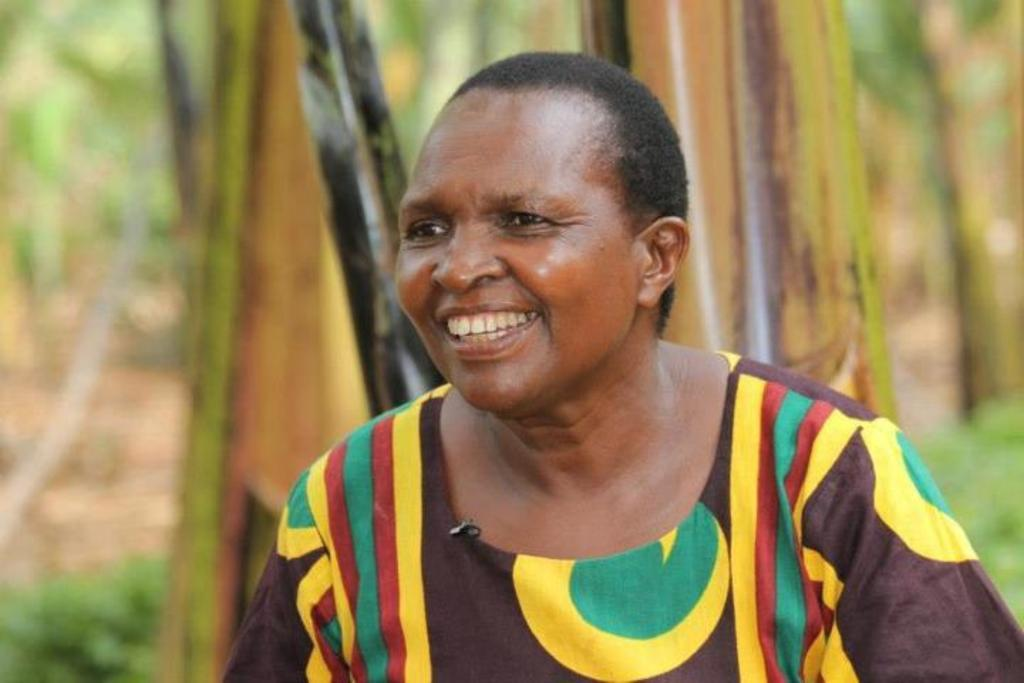Who is present in the image? There is a woman in the image. What is the woman doing in the image? The woman is laughing in the image. Where was the image likely taken? The image appears to be taken outdoors. What can be seen in the background of the image? There are trees in the background of the image. What type of ground is visible at the bottom of the image? There is green grass at the bottom of the image. What type of yarn is the woman using to adjust her parcel in the image? There is no yarn or parcel present in the image; the woman is simply laughing outdoors. 